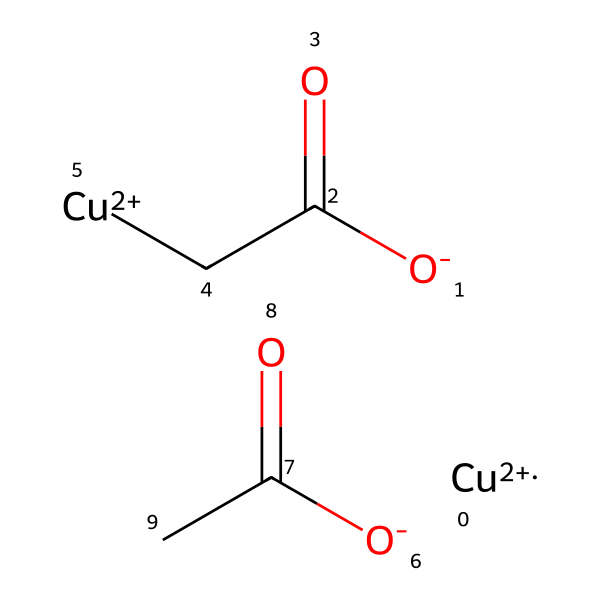how many copper atoms are in the structure? The SMILES representation contains two instances of [Cu+2], indicating there are two copper atoms present in the molecular arrangement.
Answer: two what type of bond connects the copper atoms to the other components? The copper atoms are coordinated through ionic interactions with the negatively charged oxygen atoms (O-) in the carboxylate groups (C(=O)C), forming ionic bonds.
Answer: ionic bonds what are the main components of verdigris based on this structure? The structure indicates that verdigris primarily consists of copper ions and organic acids, as represented by the carboxylate groups (O- and C(=O)).
Answer: copper ions and organic acids how many total oxygen atoms are present in the molecule? Each of the two carboxylate groups contributes two oxygen atoms, giving a total of four oxygen atoms (two from each group contributes two O each).
Answer: four what chemical feature distinguishes verdigris as an organosulfur compound? Verdigris contains organic acids but lacks sulfur atoms; thus, it does not possess distinguishing organosulfur features. Although related to organosulfur compounds, verdigris itself does not classify as one.
Answer: lacks distinguishing features what role do the copper ions play in the chemical's properties? Copper ions provide the characteristic green color and are essential for the pigment’s stability and reactivity, especially in the context of degrading bronze artifacts.
Answer: provide color and stability 